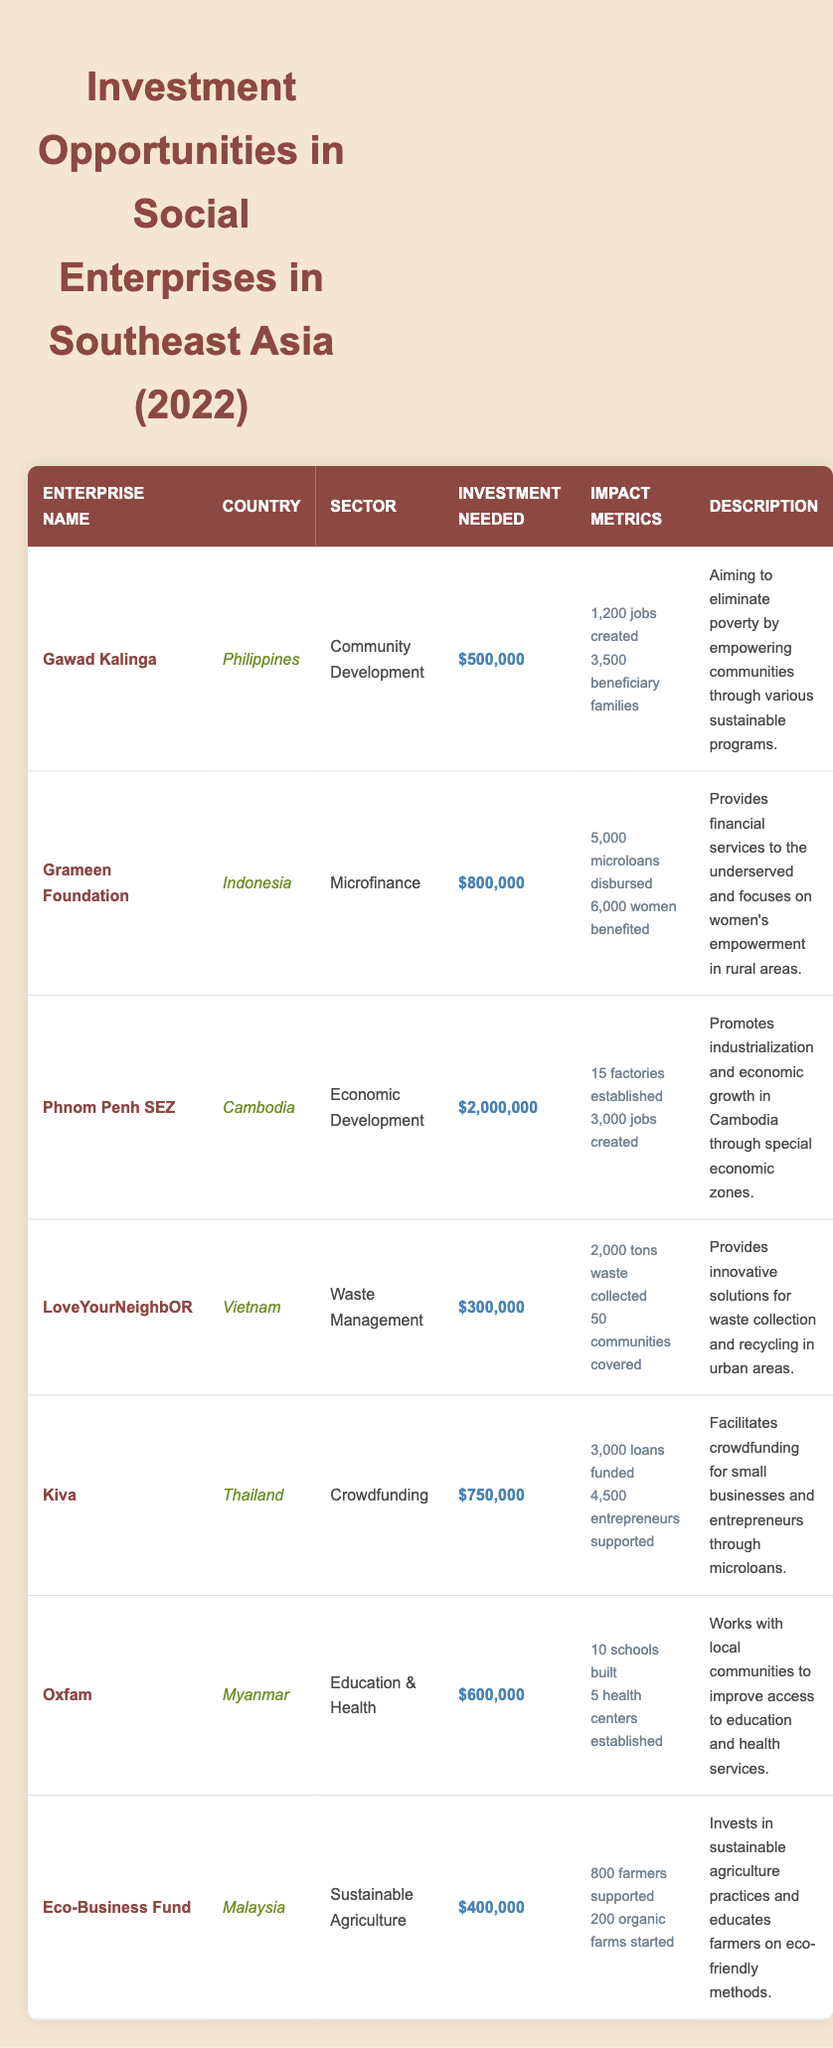What is the investment needed for Gawad Kalinga? According to the table, Gawad Kalinga requires an investment of $500,000, as stated under the "Investment Needed" column.
Answer: $500,000 Which enterprise has the highest investment needed? By comparing the "Investment Needed" values, Phnom Penh SEZ requires the most investment at $2,000,000.
Answer: Phnom Penh SEZ How many jobs are created by LoveYourNeighbOR? The table indicates that LoveYourNeighbOR has created 2,000 tons of waste collected, but the specific number of jobs created is not listed. Thus, we focus on available data; however, it does state the benefits to communities.
Answer: Not applicable (data missing) What is the total number of jobs created by Gawad Kalinga and Phnom Penh SEZ combined? Gawad Kalinga created 1,200 jobs and Phnom Penh SEZ created 3,000 jobs. Adding these two values gives 1,200 + 3,000 = 4,200 jobs created altogether.
Answer: 4,200 How many women benefited from the Grameen Foundation? The table specifies that 6,000 women have benefited from the Grameen Foundation's services, as shown in the "Impact Metrics" section.
Answer: 6,000 Which country has the enterprise focused on education and health? Oxfam operates in Myanmar and focuses on education and health, as found by reviewing the "Country" and "Sector" columns.
Answer: Myanmar Is the Eco-Business Fund's investment needed less than $500,000? The Eco-Business Fund requires an investment of $400,000, which is indeed less than $500,000, confirming the statement as true.
Answer: Yes How many farmers are supported by Eco-Business Fund compared to the number of beneficiaries from Gawad Kalinga? Eco-Business Fund supports 800 farmers while Gawad Kalinga has 3,500 beneficiary families. We see that 800 is less than 3,500. Hence, Eco-Business Fund supports fewer individuals than Gawad Kalinga.
Answer: Less What is the total investment needed for all social enterprises listed? To find the total investment needed, we sum the amounts for all enterprises: $500,000 + $800,000 + $2,000,000 + $300,000 + $750,000 + $600,000 + $400,000 = $5,350,000.
Answer: $5,350,000 Which sectors have enterprises from Vietnam? The table shows that the sector for LoveYourNeighbOR in Vietnam is Waste Management. Therefore, it is the only enterprise listed in this country type shown in the table.
Answer: Waste Management Calculate the average investment needed across all enterprises listed. To find the average, we first calculate the total investment, which is $5,350,000 (from the previous calculation) and divide it by the number of enterprises, which is 7. Hence, the average is $5,350,000 / 7 ≈ $764,285.71.
Answer: $764,286 (rounded) 